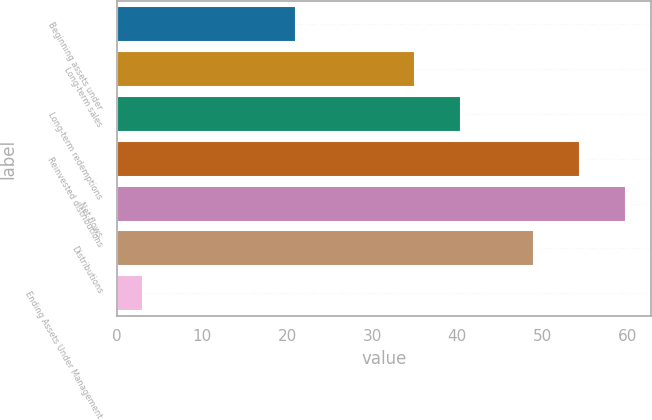Convert chart. <chart><loc_0><loc_0><loc_500><loc_500><bar_chart><fcel>Beginning assets under<fcel>Long-term sales<fcel>Long-term redemptions<fcel>Reinvested distributions<fcel>Net flows<fcel>Distributions<fcel>Ending Assets Under Management<nl><fcel>21<fcel>35<fcel>40.4<fcel>54.4<fcel>59.8<fcel>49<fcel>3<nl></chart> 